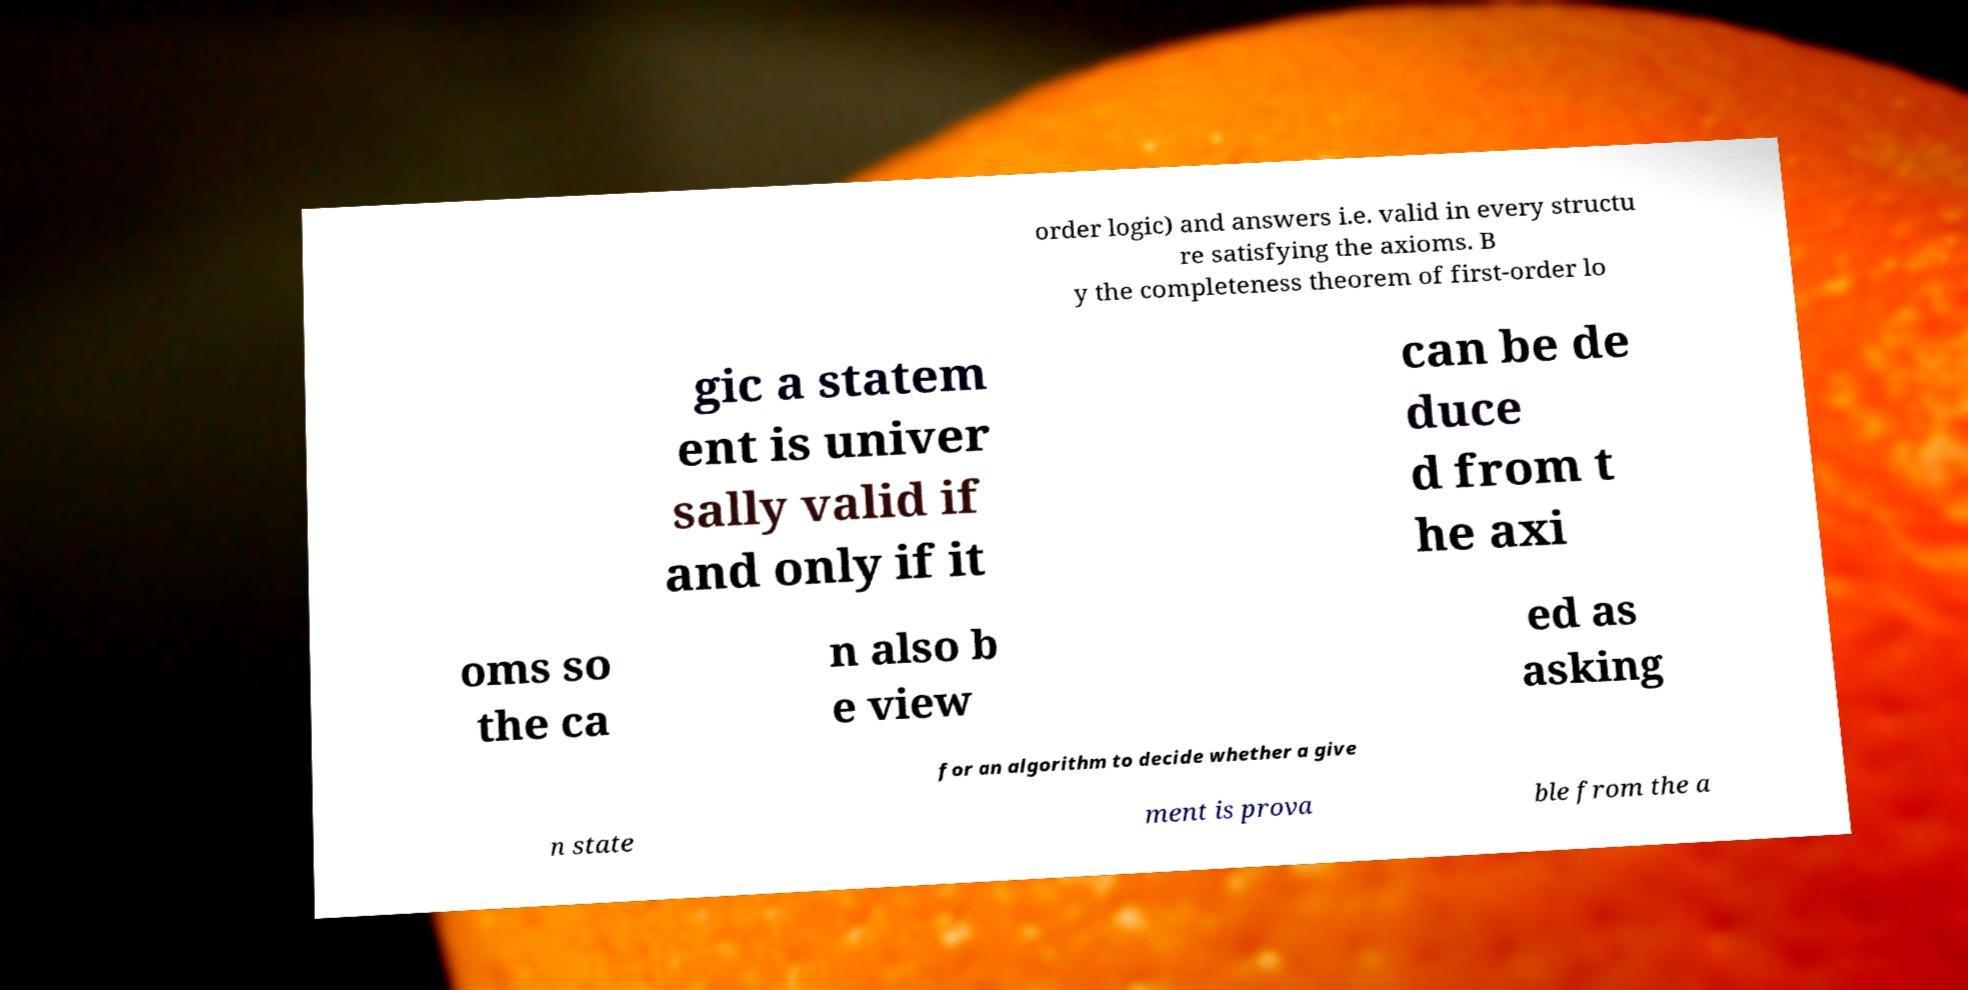Could you extract and type out the text from this image? order logic) and answers i.e. valid in every structu re satisfying the axioms. B y the completeness theorem of first-order lo gic a statem ent is univer sally valid if and only if it can be de duce d from t he axi oms so the ca n also b e view ed as asking for an algorithm to decide whether a give n state ment is prova ble from the a 